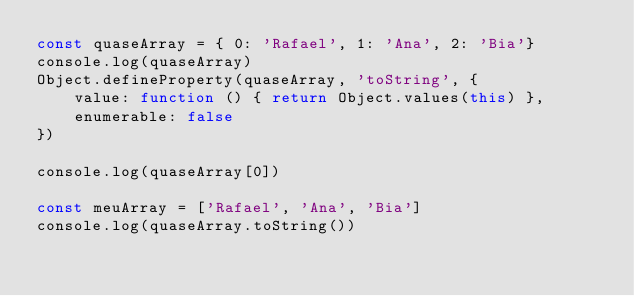Convert code to text. <code><loc_0><loc_0><loc_500><loc_500><_JavaScript_>const quaseArray = { 0: 'Rafael', 1: 'Ana', 2: 'Bia'}
console.log(quaseArray)
Object.defineProperty(quaseArray, 'toString', {
    value: function () { return Object.values(this) },
    enumerable: false
})

console.log(quaseArray[0])

const meuArray = ['Rafael', 'Ana', 'Bia']
console.log(quaseArray.toString())</code> 